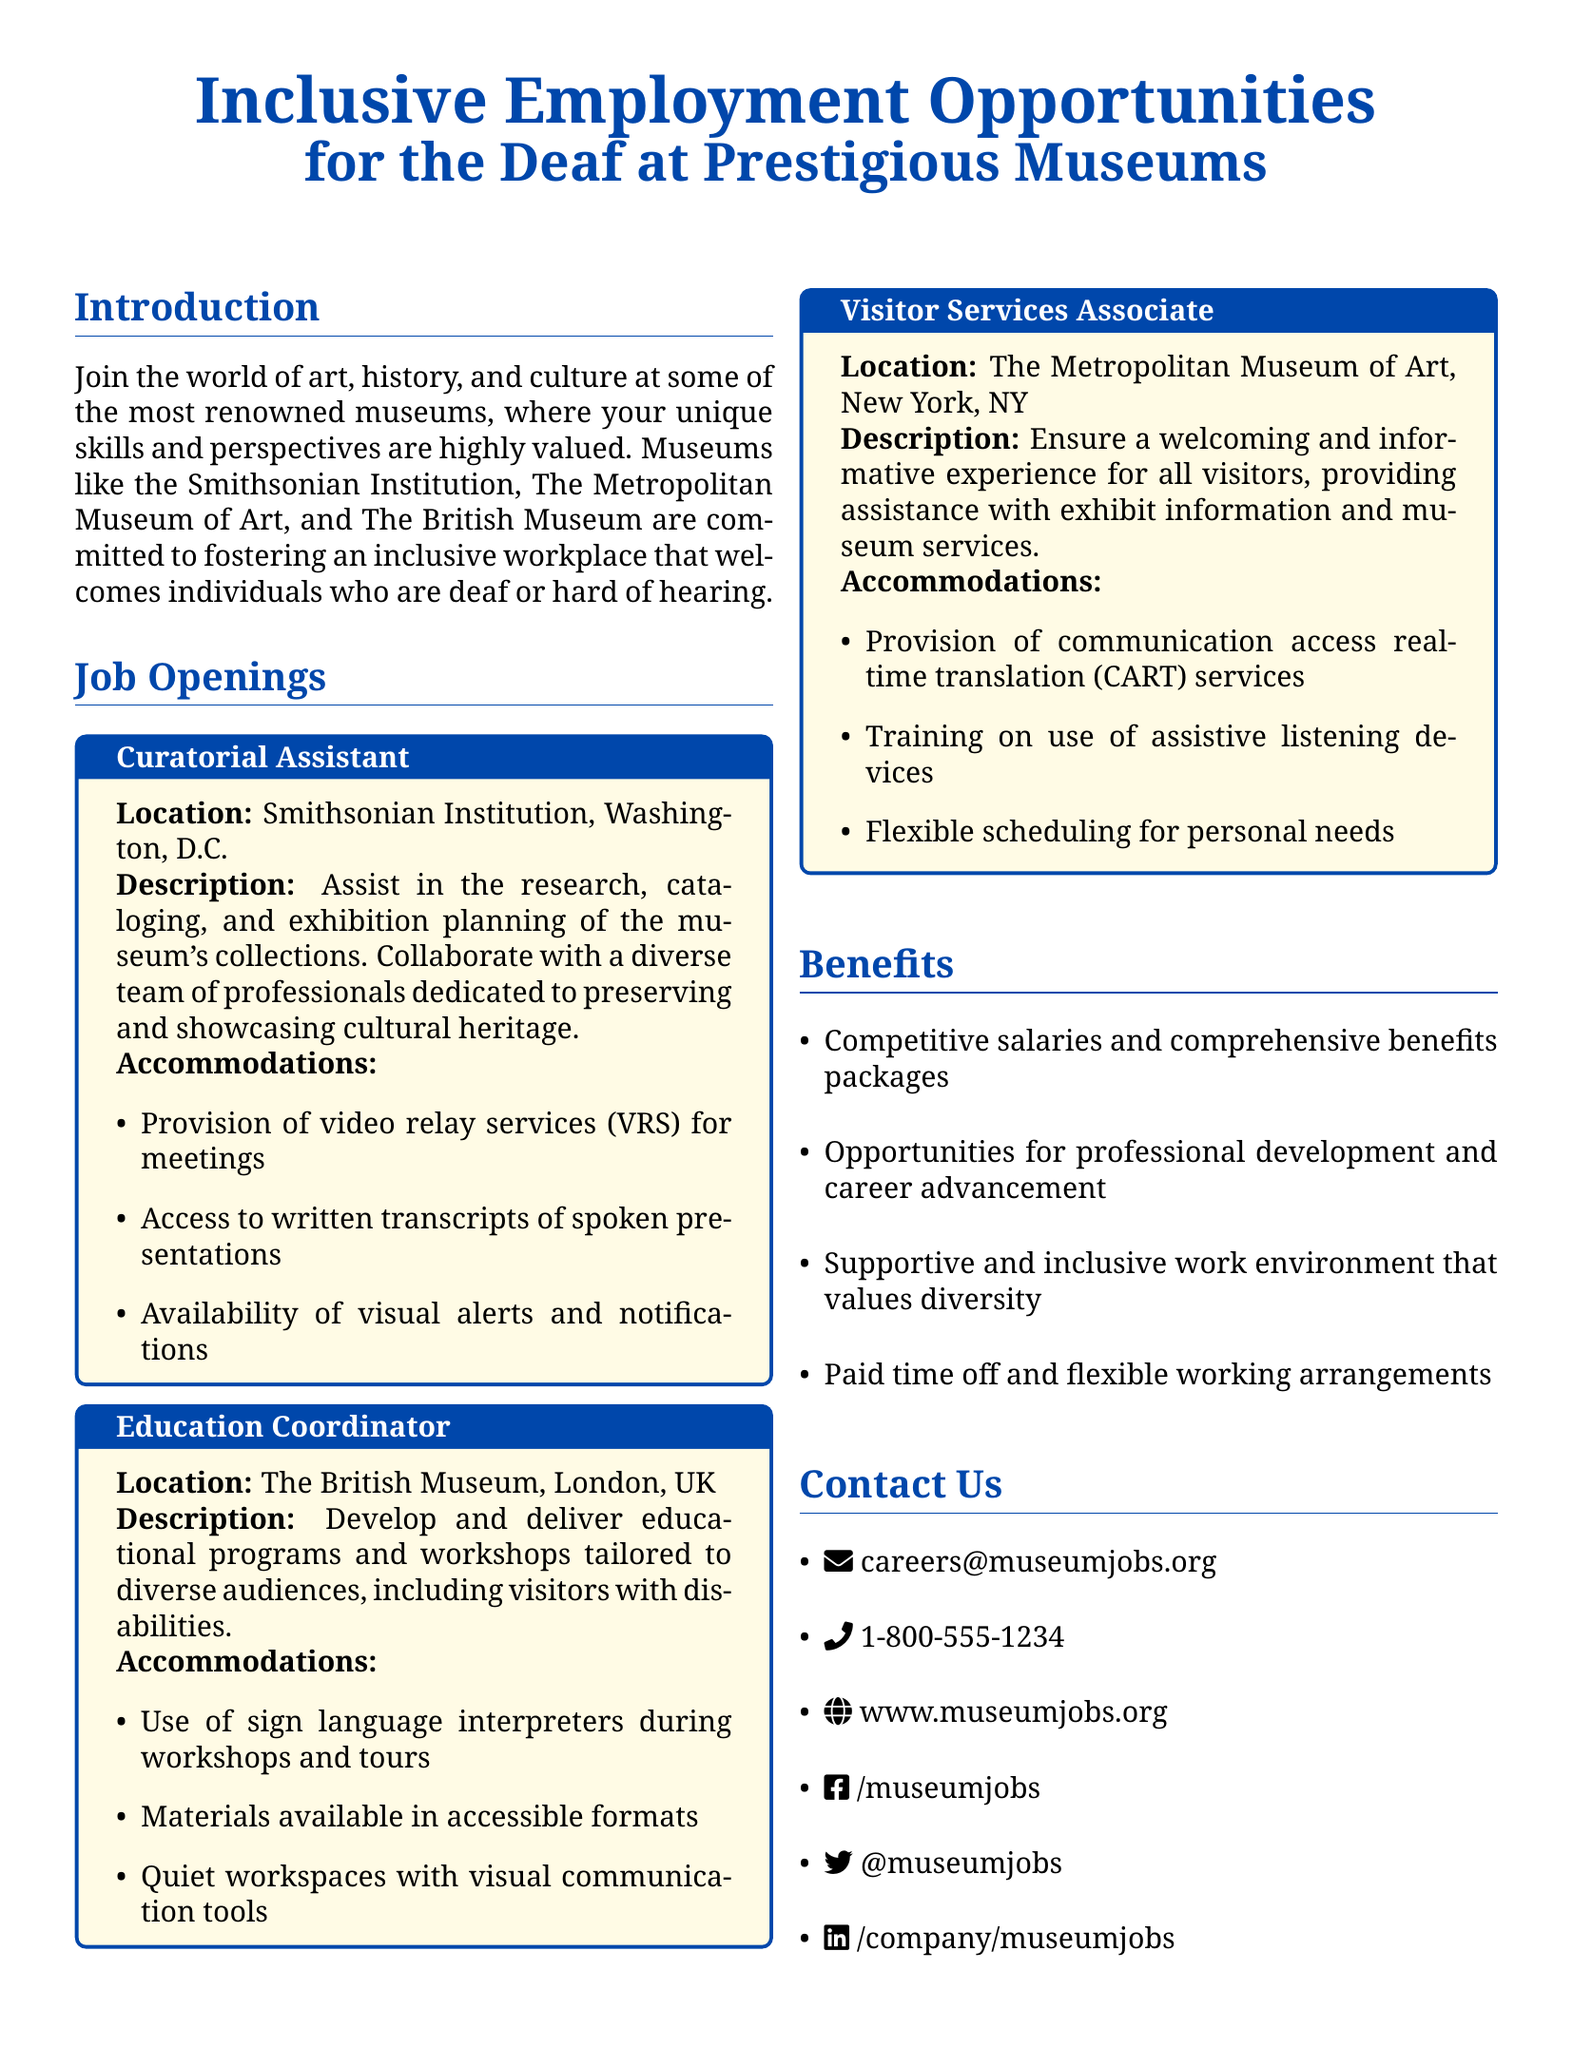what is the job title at the Smithsonian Institution? The job title at the Smithsonian Institution is "Curatorial Assistant."
Answer: Curatorial Assistant what is one responsibility of the Education Coordinator? The Education Coordinator is responsible for developing and delivering educational programs and workshops.
Answer: Develop educational programs how many job openings are listed in the document? There are three job openings listed in the document.
Answer: Three which museum offers the position of Visitor Services Associate? The position of Visitor Services Associate is offered at The Metropolitan Museum of Art.
Answer: The Metropolitan Museum of Art what type of accommodation is provided for the Curatorial Assistant? One of the accommodations for the Curatorial Assistant is the provision of video relay services (VRS) for meetings.
Answer: Video relay services (VRS) what is the contact email for museum job inquiries? The contact email for inquiries is careers@museumjobs.org.
Answer: careers@museumjobs.org what accommodations are mentioned for the Visitor Services Associate? Accommodations for the Visitor Services Associate include communication access real-time translation (CART) services.
Answer: CART services where is the location of the Education Coordinator role? The location of the Education Coordinator role is The British Museum, London, UK.
Answer: The British Museum, London, UK what is one benefit mentioned in the document? One benefit mentioned is competitive salaries and comprehensive benefits packages.
Answer: Competitive salaries 